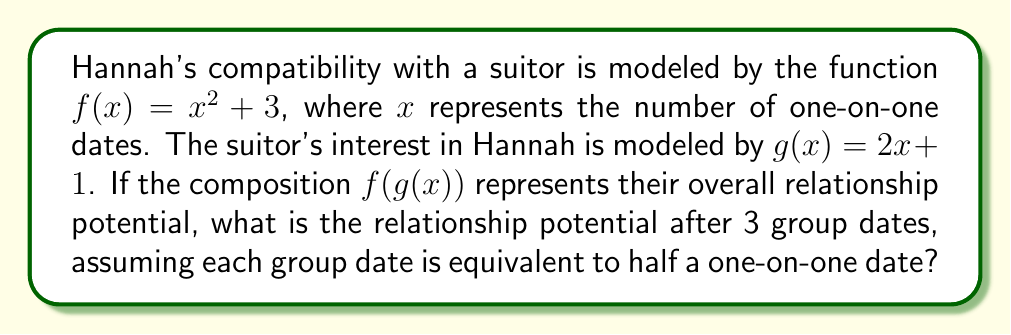Could you help me with this problem? Let's approach this step-by-step:

1) First, we need to determine the input for $g(x)$. Since 3 group dates are equivalent to half a one-on-one date each:
   $3 \cdot \frac{1}{2} = 1.5$ one-on-one dates

2) Now, we apply $g(x)$ to this value:
   $g(1.5) = 2(1.5) + 1 = 3 + 1 = 4$

3) The result of $g(x)$ becomes the input for $f(x)$. So we now calculate $f(4)$:
   $f(4) = 4^2 + 3 = 16 + 3 = 19$

4) Therefore, $f(g(1.5)) = 19$

This means that after 3 group dates (equivalent to 1.5 one-on-one dates), the overall relationship potential is 19 on Hannah's compatibility scale.
Answer: 19 